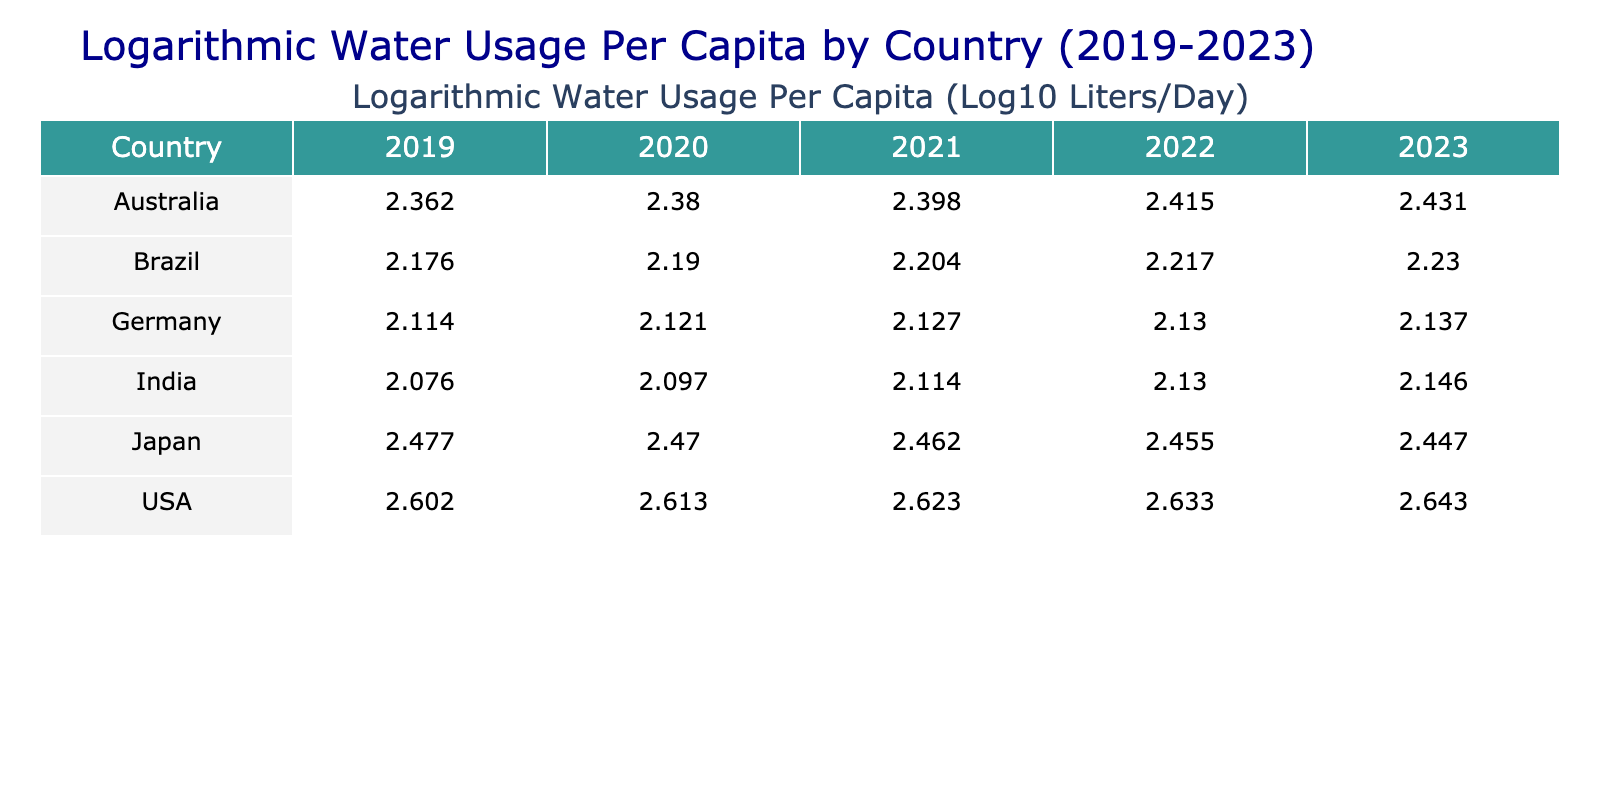What was the water usage per capita in Germany in 2021? The table indicates that the water usage per capita in Germany for the year 2021 is listed directly under the 2021 column for Germany. The value is 134 liters per day.
Answer: 134 Which country had the highest water usage per capita in 2023? To find the country with the highest water usage in 2023, we look down the 2023 column. The highest value in this column is 440 liters per day for the USA, compared to other countries listed.
Answer: USA What is the average water usage per capita for India over the five years? To find the average for India, sum the values for the years 2019 to 2023: 119 + 125 + 130 + 135 + 140 = 649. Then divide this sum by the number of years (5) to get the average: 649 / 5 = 129.8.
Answer: 129.8 Did Japan's water usage per capita increase over the five years? Looking at the values for Japan from 2019 to 2023, they are 300, 295, 290, 285, and 280 respectively, showing a continual decrease. Thus, Japan’s water usage did not increase over these years.
Answer: No What is the difference in water usage per capita between the USA and Australia in 2022? The value for the USA in 2022 is 430 liters per day, while for Australia, it is 260 liters per day. Subtract the Australian figure from the USA's: 430 - 260 = 170 liters.
Answer: 170 What was the total water usage per capita for Brazil from 2019 to 2023? The water usage per capita for Brazil over the years is 150, 155, 160, 165, and 170. Adding these together gives: 150 + 155 + 160 + 165 + 170 = 800 liters.
Answer: 800 Is it true that Germany has maintained a water usage above 130 liters per capita over the years 2019 to 2023? Checking the values for Germany shows that in 2019 it was 130, in 2020 it was 132, in 2021 it was 134, and in 2022 it slightly increased to 135; however, in 2023, it rose to 137. Therefore, the statement is true.
Answer: Yes Which country had the lowest water usage per capita in 2020? In 2020, the values are 410 for the USA, 132 for Germany, 125 for India, 155 for Brazil, 295 for Japan, and 240 for Australia. The lowest value in this set is for India at 125 liters per day.
Answer: India What trend does Australia show in water usage per capita over the five years? Analyzing Australia's figures over the years, we see a sequence of increasing values: 230, 240, 250, 260, and 270. This indicates a consistent upward trend in water usage per capita.
Answer: Increasing 